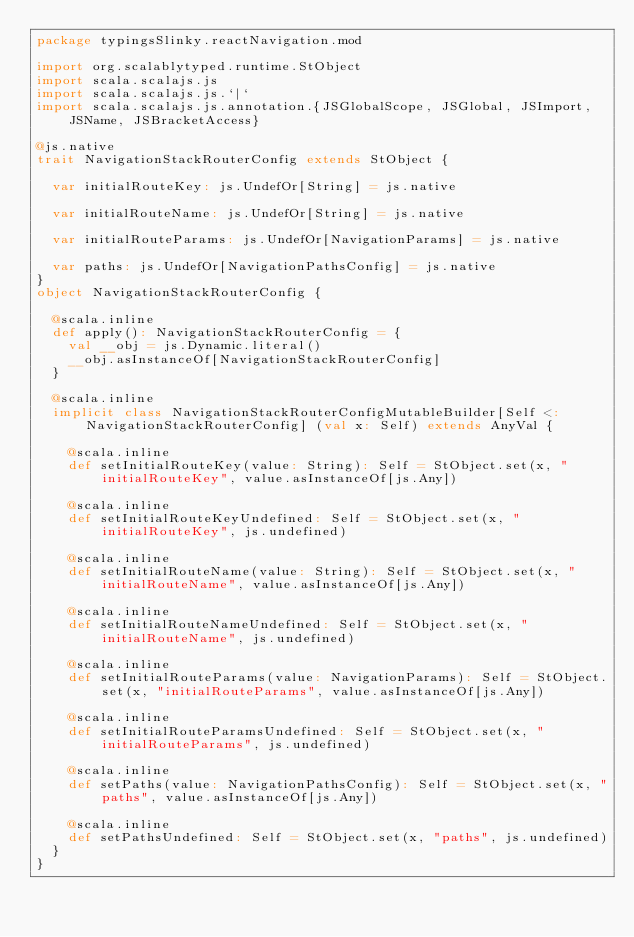Convert code to text. <code><loc_0><loc_0><loc_500><loc_500><_Scala_>package typingsSlinky.reactNavigation.mod

import org.scalablytyped.runtime.StObject
import scala.scalajs.js
import scala.scalajs.js.`|`
import scala.scalajs.js.annotation.{JSGlobalScope, JSGlobal, JSImport, JSName, JSBracketAccess}

@js.native
trait NavigationStackRouterConfig extends StObject {
  
  var initialRouteKey: js.UndefOr[String] = js.native
  
  var initialRouteName: js.UndefOr[String] = js.native
  
  var initialRouteParams: js.UndefOr[NavigationParams] = js.native
  
  var paths: js.UndefOr[NavigationPathsConfig] = js.native
}
object NavigationStackRouterConfig {
  
  @scala.inline
  def apply(): NavigationStackRouterConfig = {
    val __obj = js.Dynamic.literal()
    __obj.asInstanceOf[NavigationStackRouterConfig]
  }
  
  @scala.inline
  implicit class NavigationStackRouterConfigMutableBuilder[Self <: NavigationStackRouterConfig] (val x: Self) extends AnyVal {
    
    @scala.inline
    def setInitialRouteKey(value: String): Self = StObject.set(x, "initialRouteKey", value.asInstanceOf[js.Any])
    
    @scala.inline
    def setInitialRouteKeyUndefined: Self = StObject.set(x, "initialRouteKey", js.undefined)
    
    @scala.inline
    def setInitialRouteName(value: String): Self = StObject.set(x, "initialRouteName", value.asInstanceOf[js.Any])
    
    @scala.inline
    def setInitialRouteNameUndefined: Self = StObject.set(x, "initialRouteName", js.undefined)
    
    @scala.inline
    def setInitialRouteParams(value: NavigationParams): Self = StObject.set(x, "initialRouteParams", value.asInstanceOf[js.Any])
    
    @scala.inline
    def setInitialRouteParamsUndefined: Self = StObject.set(x, "initialRouteParams", js.undefined)
    
    @scala.inline
    def setPaths(value: NavigationPathsConfig): Self = StObject.set(x, "paths", value.asInstanceOf[js.Any])
    
    @scala.inline
    def setPathsUndefined: Self = StObject.set(x, "paths", js.undefined)
  }
}
</code> 